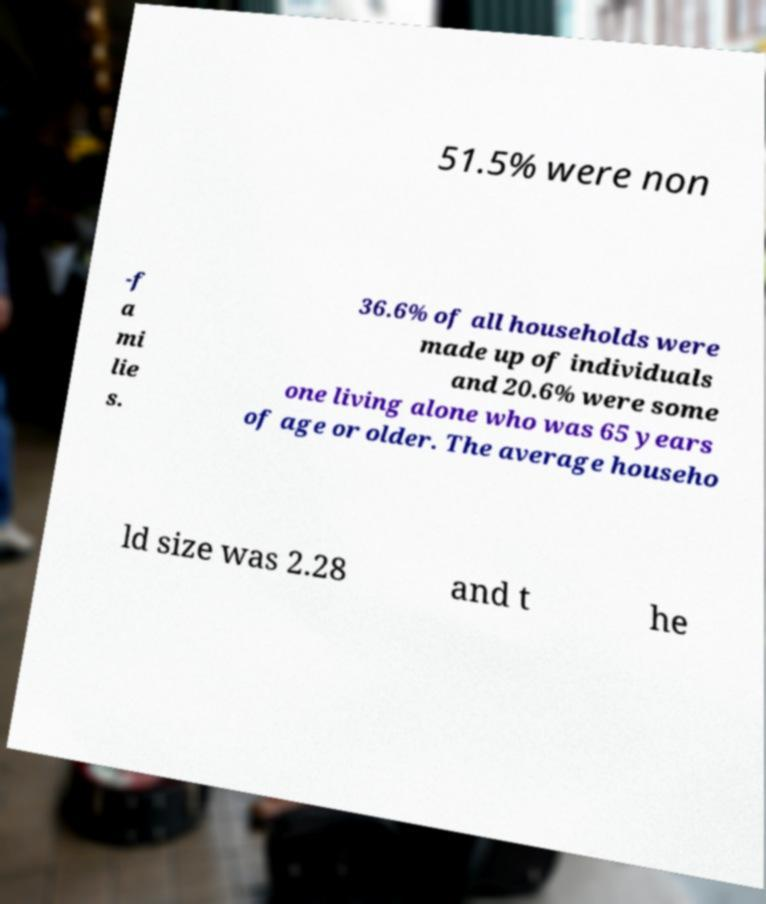Please read and relay the text visible in this image. What does it say? 51.5% were non -f a mi lie s. 36.6% of all households were made up of individuals and 20.6% were some one living alone who was 65 years of age or older. The average househo ld size was 2.28 and t he 